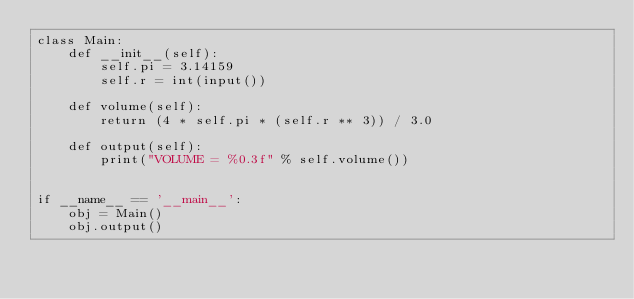Convert code to text. <code><loc_0><loc_0><loc_500><loc_500><_Python_>class Main:
    def __init__(self):
        self.pi = 3.14159
        self.r = int(input())

    def volume(self):
        return (4 * self.pi * (self.r ** 3)) / 3.0

    def output(self):
        print("VOLUME = %0.3f" % self.volume())


if __name__ == '__main__':
    obj = Main()
    obj.output()
</code> 